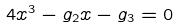Convert formula to latex. <formula><loc_0><loc_0><loc_500><loc_500>4 x ^ { 3 } - g _ { 2 } x - g _ { 3 } = 0</formula> 